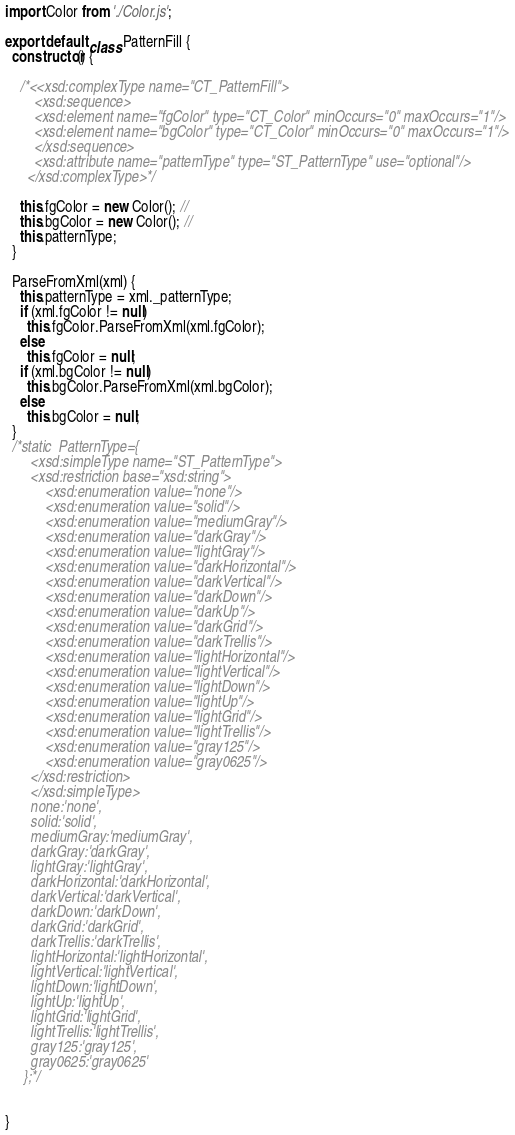Convert code to text. <code><loc_0><loc_0><loc_500><loc_500><_JavaScript_>import Color from './Color.js';

export default class PatternFill {
  constructor() {

    /*<<xsd:complexType name="CT_PatternFill">
        <xsd:sequence>
        <xsd:element name="fgColor" type="CT_Color" minOccurs="0" maxOccurs="1"/>
        <xsd:element name="bgColor" type="CT_Color" minOccurs="0" maxOccurs="1"/>
        </xsd:sequence>
        <xsd:attribute name="patternType" type="ST_PatternType" use="optional"/>
      </xsd:complexType>*/

    this.fgColor = new Color(); //
    this.bgColor = new Color(); //
    this.patternType;
  }

  ParseFromXml(xml) {
    this.patternType = xml._patternType;
    if (xml.fgColor != null)
      this.fgColor.ParseFromXml(xml.fgColor);
    else
      this.fgColor = null;
    if (xml.bgColor != null)
      this.bgColor.ParseFromXml(xml.bgColor);
    else
      this.bgColor = null;
  }
  /*static  PatternType={
       <xsd:simpleType name="ST_PatternType">
       <xsd:restriction base="xsd:string">
           <xsd:enumeration value="none"/>
           <xsd:enumeration value="solid"/>
           <xsd:enumeration value="mediumGray"/>
           <xsd:enumeration value="darkGray"/>
           <xsd:enumeration value="lightGray"/>
           <xsd:enumeration value="darkHorizontal"/>
           <xsd:enumeration value="darkVertical"/>
           <xsd:enumeration value="darkDown"/>
           <xsd:enumeration value="darkUp"/>
           <xsd:enumeration value="darkGrid"/>
           <xsd:enumeration value="darkTrellis"/>
           <xsd:enumeration value="lightHorizontal"/>
           <xsd:enumeration value="lightVertical"/>
           <xsd:enumeration value="lightDown"/>
           <xsd:enumeration value="lightUp"/>
           <xsd:enumeration value="lightGrid"/>
           <xsd:enumeration value="lightTrellis"/>
           <xsd:enumeration value="gray125"/>
           <xsd:enumeration value="gray0625"/>
       </xsd:restriction>
       </xsd:simpleType>
       none:'none',
       solid:'solid',
       mediumGray:'mediumGray',
       darkGray:'darkGray',
       lightGray:'lightGray',
       darkHorizontal:'darkHorizontal',
       darkVertical:'darkVertical',
       darkDown:'darkDown',
       darkGrid:'darkGrid',
       darkTrellis:'darkTrellis',
       lightHorizontal:'lightHorizontal',
       lightVertical:'lightVertical',
       lightDown:'lightDown',
       lightUp:'lightUp',
       lightGrid:'lightGrid',
       lightTrellis:'lightTrellis',
       gray125:'gray125',
       gray0625:'gray0625'
     };*/


}
</code> 